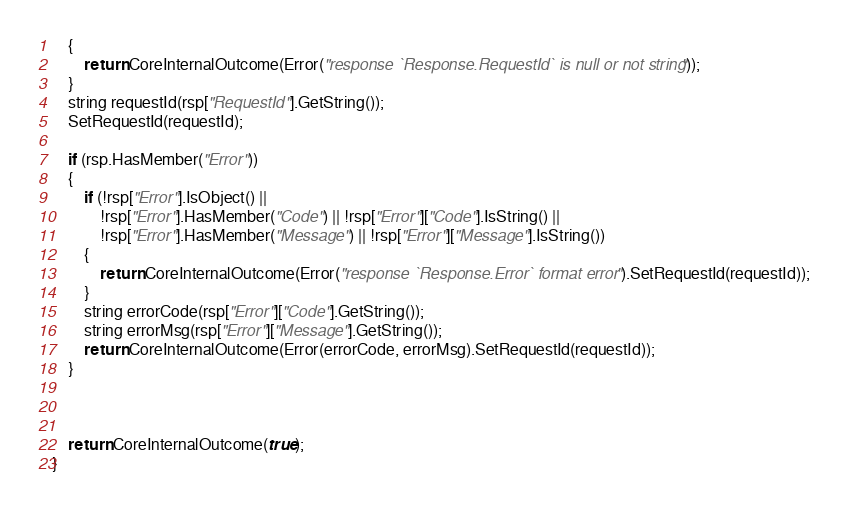Convert code to text. <code><loc_0><loc_0><loc_500><loc_500><_C++_>    {
        return CoreInternalOutcome(Error("response `Response.RequestId` is null or not string"));
    }
    string requestId(rsp["RequestId"].GetString());
    SetRequestId(requestId);

    if (rsp.HasMember("Error"))
    {
        if (!rsp["Error"].IsObject() ||
            !rsp["Error"].HasMember("Code") || !rsp["Error"]["Code"].IsString() ||
            !rsp["Error"].HasMember("Message") || !rsp["Error"]["Message"].IsString())
        {
            return CoreInternalOutcome(Error("response `Response.Error` format error").SetRequestId(requestId));
        }
        string errorCode(rsp["Error"]["Code"].GetString());
        string errorMsg(rsp["Error"]["Message"].GetString());
        return CoreInternalOutcome(Error(errorCode, errorMsg).SetRequestId(requestId));
    }



    return CoreInternalOutcome(true);
}



</code> 